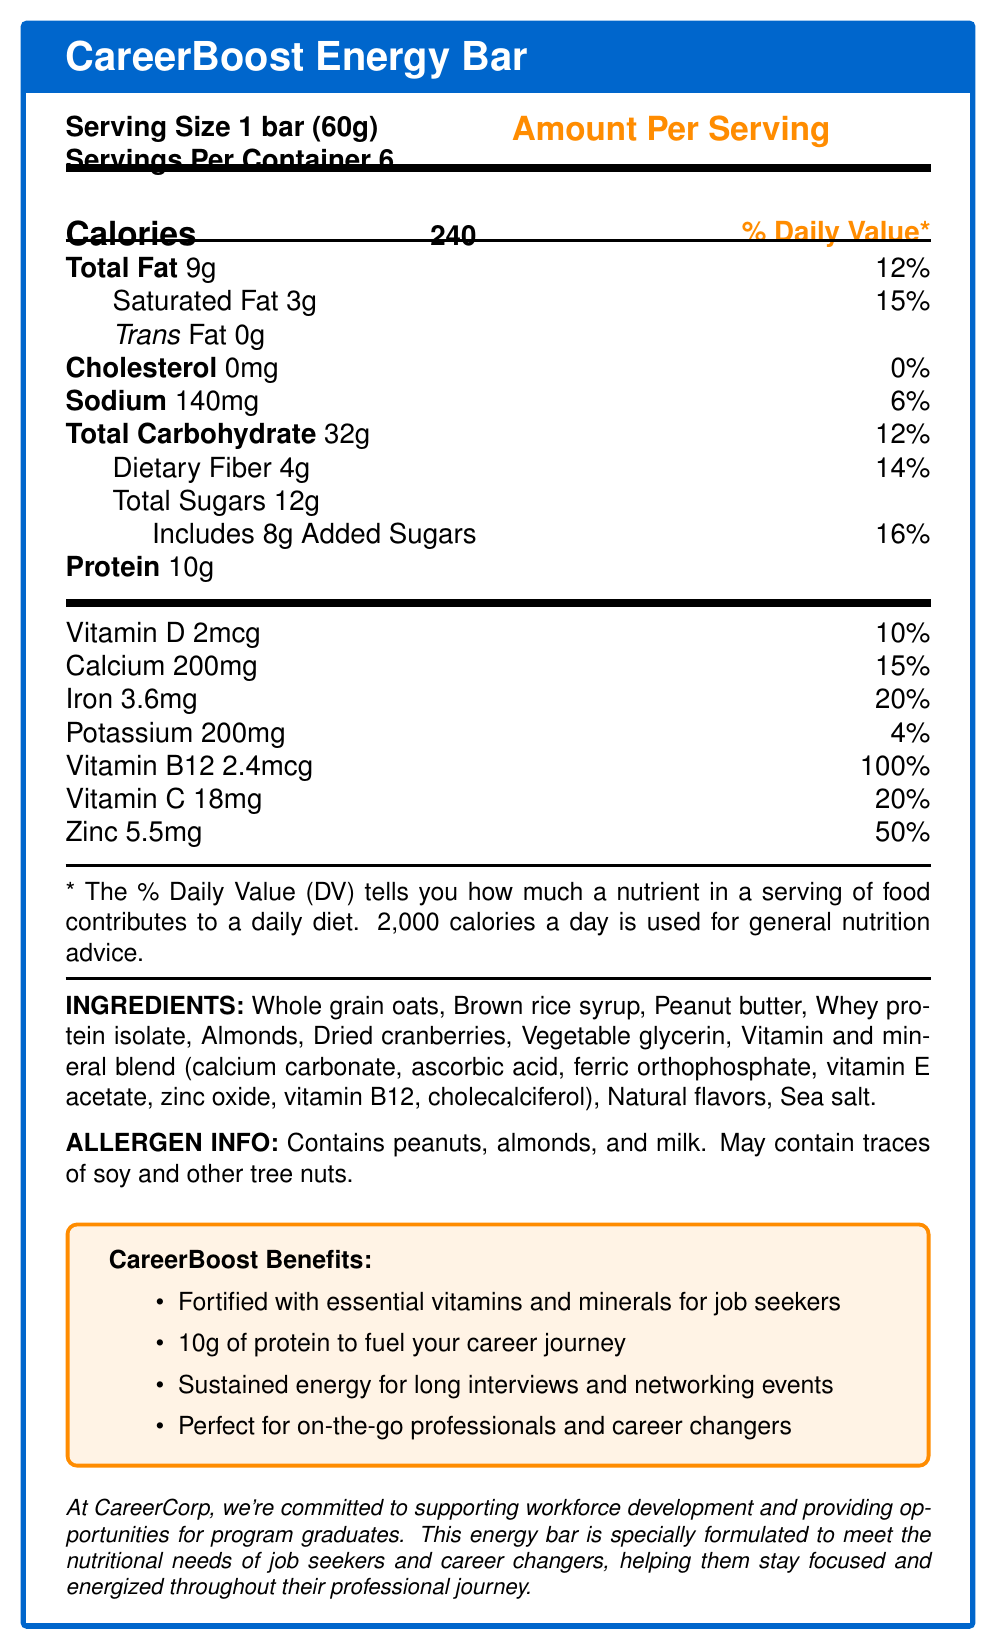what is the serving size of the CareerBoost Energy Bar? The serving size is clearly listed as "1 bar (60g)" in the Nutrition Facts section of the document.
Answer: 1 bar (60g) how many calories are in one serving of the CareerBoost Energy Bar? The amount of calories per serving is indicated as 240 under the "Calories" section.
Answer: 240 calories what is the percentage of daily value for saturated fat in one serving of the energy bar? The daily value percentage for saturated fat is listed as 15% next to the "Saturated Fat" amount.
Answer: 15% what is the amount of protein in a single CareerBoost Energy Bar? The amount of protein in one bar is listed as 10g under the "Protein" section.
Answer: 10g which vitamin has the highest daily value percentage in the CareerBoost Energy Bar? The daily value percentage for Vitamin B12 is the highest at 100%, as listed in the vitamin and mineral content section.
Answer: Vitamin B12 which ingredient lists contains allergens? A. Whole grain oats B. Brown rice syrup C. Peanuts D. Sea salt The allergen information section specifically mentions that the product contains peanuts.
Answer: C how many servings are in each container of the CareerBoost Energy Bar? A. 4 B. 6 C. 10 D. 8 The servings per container are listed as 6.
Answer: B what is the daily value percentage for Calcium provided in one energy bar? A. 10% B. 15% C. 20% D. 50% The daily value percentage for Calcium is given as 15%.
Answer: B does the CareerBoost Energy Bar contain any added sugars? The nutrition label lists "Includes 8g Added Sugars" confirming the presence of added sugars.
Answer: Yes is the product suitable for someone with a tree nut allergy? The allergen info states that it contains almonds and may contain traces of other tree nuts.
Answer: No summarize the main purpose of the CareerBoost Energy Bar according to the document. The document highlights the bar's nutritional content aimed at helping professionals stay energized and focused through long interviews and networking events. It also emphasizes the company's commitment to workforce development.
Answer: The CareerBoost Energy Bar is designed to provide nutritional support for job seekers and career changers by offering a fortified energy bar with essential vitamins and minerals, 10g of protein, and sustained energy. what are some of the marketing claims made about the CareerBoost Energy Bar? Under the "CareerBoost Benefits" section, the bar is marketed as being fortified with essential vitamins and minerals for job seekers, containing 10g of protein, providing sustained energy for long events, and being suitable for on-the-go professionals and career changers.
Answer: Fortified with essential vitamins and minerals, 10g of protein, sustained energy, perfect for on-the-go professionals. which nutrient has the lowest daily value percentage in the energy bar? The nutrition label shows that Potassium has the lowest daily value percentage at 4%.
Answer: Potassium how many grams of dietary fiber does the CareerBoost Energy Bar contain? The amount of dietary fiber is listed as 4g under the "Total Carbohydrate" section.
Answer: 4g what specific demographic is the CareerBoost Energy Bar targeted towards? The company statement and marketing claims explicitly mention that the product is designed for job seekers and career changers.
Answer: Job seekers and career changers does the CareerBoost Energy Bar contain any trans fat? The nutrition label shows 0g of trans fat.
Answer: No how much sodium is in one bar of the CareerBoost Energy Bar? The amount of sodium per serving is listed as 140mg under the "Sodium" section.
Answer: 140mg list three main ingredients of the CareerBoost Energy Bar. The main ingredients are listed as whole grain oats, brown rice syrup, and peanut butter among others in the ingredient section.
Answer: Whole grain oats, Brown rice syrup, Peanut butter what is the weight of one container of CareerBoost Energy Bars? The document provides information on serving size and servings per container, but not the total weight of the container.
Answer: Cannot be determined 